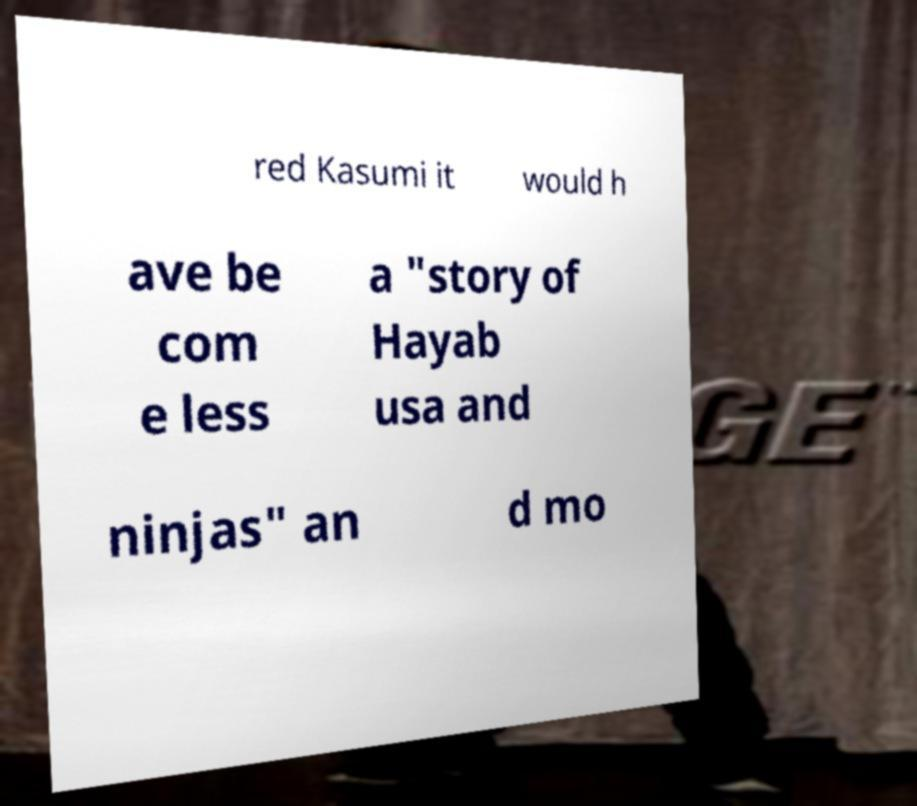Can you accurately transcribe the text from the provided image for me? red Kasumi it would h ave be com e less a "story of Hayab usa and ninjas" an d mo 